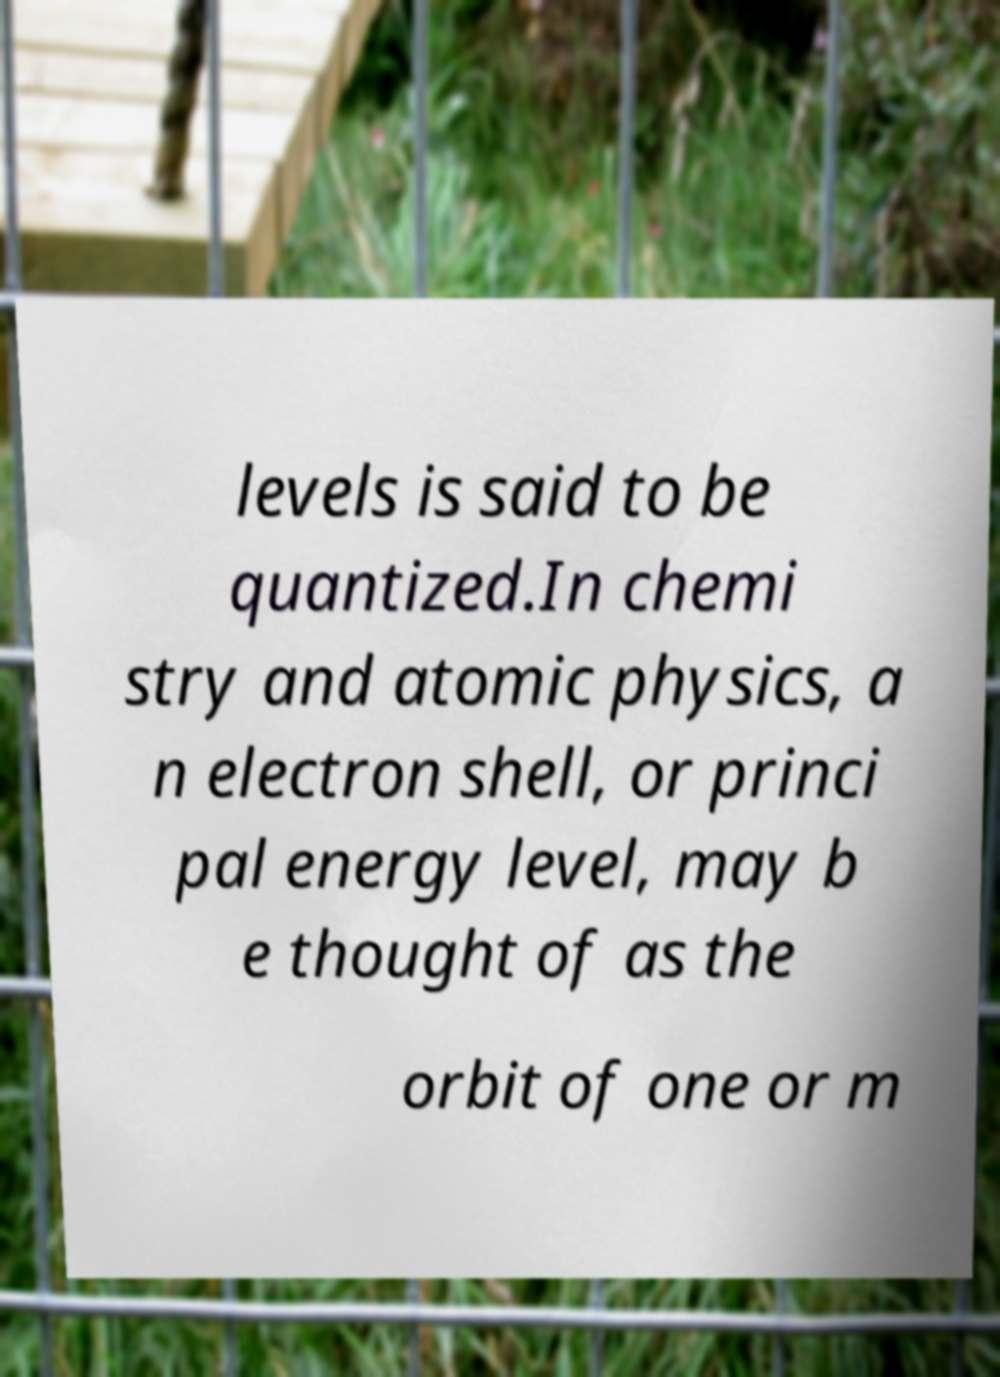Could you extract and type out the text from this image? levels is said to be quantized.In chemi stry and atomic physics, a n electron shell, or princi pal energy level, may b e thought of as the orbit of one or m 